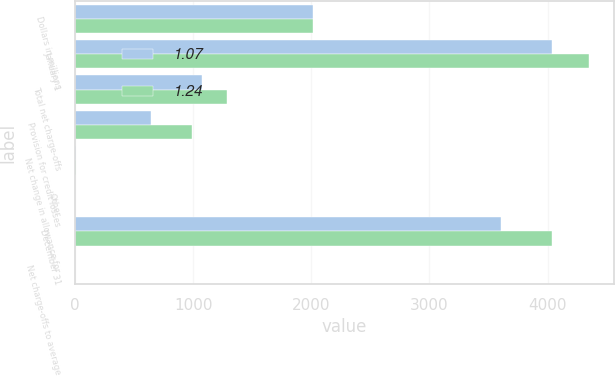Convert chart. <chart><loc_0><loc_0><loc_500><loc_500><stacked_bar_chart><ecel><fcel>Dollars in millions<fcel>January 1<fcel>Total net charge-offs<fcel>Provision for credit losses<fcel>Net change in allowance for<fcel>Other<fcel>December 31<fcel>Net charge-offs to average<nl><fcel>1.07<fcel>2013<fcel>4036<fcel>1077<fcel>643<fcel>8<fcel>1<fcel>3609<fcel>0.57<nl><fcel>1.24<fcel>2012<fcel>4347<fcel>1289<fcel>987<fcel>10<fcel>1<fcel>4036<fcel>0.73<nl></chart> 